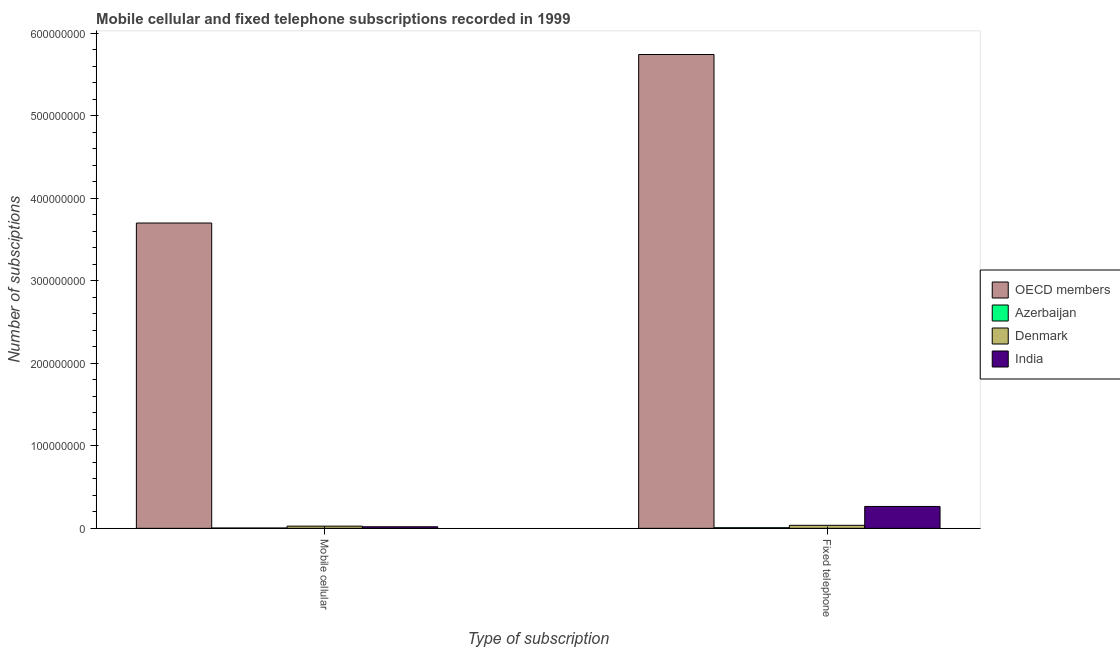How many groups of bars are there?
Your answer should be very brief. 2. What is the label of the 2nd group of bars from the left?
Give a very brief answer. Fixed telephone. What is the number of mobile cellular subscriptions in Denmark?
Keep it short and to the point. 2.63e+06. Across all countries, what is the maximum number of mobile cellular subscriptions?
Provide a short and direct response. 3.70e+08. Across all countries, what is the minimum number of fixed telephone subscriptions?
Keep it short and to the point. 7.30e+05. In which country was the number of mobile cellular subscriptions minimum?
Offer a terse response. Azerbaijan. What is the total number of fixed telephone subscriptions in the graph?
Offer a very short reply. 6.05e+08. What is the difference between the number of fixed telephone subscriptions in Azerbaijan and that in Denmark?
Make the answer very short. -2.91e+06. What is the difference between the number of mobile cellular subscriptions in India and the number of fixed telephone subscriptions in Denmark?
Offer a very short reply. -1.75e+06. What is the average number of fixed telephone subscriptions per country?
Provide a short and direct response. 1.51e+08. What is the difference between the number of mobile cellular subscriptions and number of fixed telephone subscriptions in Azerbaijan?
Make the answer very short. -3.60e+05. What is the ratio of the number of fixed telephone subscriptions in India to that in OECD members?
Your answer should be very brief. 0.05. Is the number of fixed telephone subscriptions in India less than that in Azerbaijan?
Ensure brevity in your answer.  No. In how many countries, is the number of fixed telephone subscriptions greater than the average number of fixed telephone subscriptions taken over all countries?
Offer a terse response. 1. What does the 2nd bar from the left in Fixed telephone represents?
Your response must be concise. Azerbaijan. What does the 4th bar from the right in Mobile cellular represents?
Your answer should be very brief. OECD members. How many countries are there in the graph?
Offer a terse response. 4. Are the values on the major ticks of Y-axis written in scientific E-notation?
Your answer should be very brief. No. Does the graph contain any zero values?
Make the answer very short. No. Does the graph contain grids?
Make the answer very short. No. How many legend labels are there?
Your answer should be compact. 4. What is the title of the graph?
Your answer should be compact. Mobile cellular and fixed telephone subscriptions recorded in 1999. Does "Korea (Democratic)" appear as one of the legend labels in the graph?
Provide a short and direct response. No. What is the label or title of the X-axis?
Provide a short and direct response. Type of subscription. What is the label or title of the Y-axis?
Your answer should be very brief. Number of subsciptions. What is the Number of subsciptions of OECD members in Mobile cellular?
Offer a very short reply. 3.70e+08. What is the Number of subsciptions in Azerbaijan in Mobile cellular?
Your answer should be very brief. 3.70e+05. What is the Number of subsciptions of Denmark in Mobile cellular?
Provide a short and direct response. 2.63e+06. What is the Number of subsciptions of India in Mobile cellular?
Offer a very short reply. 1.88e+06. What is the Number of subsciptions in OECD members in Fixed telephone?
Provide a short and direct response. 5.74e+08. What is the Number of subsciptions of Azerbaijan in Fixed telephone?
Provide a succinct answer. 7.30e+05. What is the Number of subsciptions of Denmark in Fixed telephone?
Provide a short and direct response. 3.64e+06. What is the Number of subsciptions of India in Fixed telephone?
Offer a very short reply. 2.65e+07. Across all Type of subscription, what is the maximum Number of subsciptions in OECD members?
Ensure brevity in your answer.  5.74e+08. Across all Type of subscription, what is the maximum Number of subsciptions of Azerbaijan?
Give a very brief answer. 7.30e+05. Across all Type of subscription, what is the maximum Number of subsciptions in Denmark?
Provide a succinct answer. 3.64e+06. Across all Type of subscription, what is the maximum Number of subsciptions in India?
Offer a very short reply. 2.65e+07. Across all Type of subscription, what is the minimum Number of subsciptions of OECD members?
Make the answer very short. 3.70e+08. Across all Type of subscription, what is the minimum Number of subsciptions in Azerbaijan?
Keep it short and to the point. 3.70e+05. Across all Type of subscription, what is the minimum Number of subsciptions of Denmark?
Offer a terse response. 2.63e+06. Across all Type of subscription, what is the minimum Number of subsciptions in India?
Provide a short and direct response. 1.88e+06. What is the total Number of subsciptions of OECD members in the graph?
Offer a terse response. 9.44e+08. What is the total Number of subsciptions in Azerbaijan in the graph?
Your response must be concise. 1.10e+06. What is the total Number of subsciptions in Denmark in the graph?
Make the answer very short. 6.27e+06. What is the total Number of subsciptions in India in the graph?
Your answer should be compact. 2.84e+07. What is the difference between the Number of subsciptions of OECD members in Mobile cellular and that in Fixed telephone?
Give a very brief answer. -2.04e+08. What is the difference between the Number of subsciptions of Azerbaijan in Mobile cellular and that in Fixed telephone?
Offer a terse response. -3.60e+05. What is the difference between the Number of subsciptions in Denmark in Mobile cellular and that in Fixed telephone?
Ensure brevity in your answer.  -1.01e+06. What is the difference between the Number of subsciptions of India in Mobile cellular and that in Fixed telephone?
Offer a terse response. -2.46e+07. What is the difference between the Number of subsciptions in OECD members in Mobile cellular and the Number of subsciptions in Azerbaijan in Fixed telephone?
Provide a short and direct response. 3.69e+08. What is the difference between the Number of subsciptions in OECD members in Mobile cellular and the Number of subsciptions in Denmark in Fixed telephone?
Provide a succinct answer. 3.66e+08. What is the difference between the Number of subsciptions of OECD members in Mobile cellular and the Number of subsciptions of India in Fixed telephone?
Your answer should be compact. 3.44e+08. What is the difference between the Number of subsciptions of Azerbaijan in Mobile cellular and the Number of subsciptions of Denmark in Fixed telephone?
Keep it short and to the point. -3.27e+06. What is the difference between the Number of subsciptions in Azerbaijan in Mobile cellular and the Number of subsciptions in India in Fixed telephone?
Offer a terse response. -2.61e+07. What is the difference between the Number of subsciptions of Denmark in Mobile cellular and the Number of subsciptions of India in Fixed telephone?
Provide a succinct answer. -2.39e+07. What is the average Number of subsciptions of OECD members per Type of subscription?
Give a very brief answer. 4.72e+08. What is the average Number of subsciptions of Azerbaijan per Type of subscription?
Keep it short and to the point. 5.50e+05. What is the average Number of subsciptions of Denmark per Type of subscription?
Offer a very short reply. 3.13e+06. What is the average Number of subsciptions of India per Type of subscription?
Ensure brevity in your answer.  1.42e+07. What is the difference between the Number of subsciptions of OECD members and Number of subsciptions of Azerbaijan in Mobile cellular?
Keep it short and to the point. 3.70e+08. What is the difference between the Number of subsciptions in OECD members and Number of subsciptions in Denmark in Mobile cellular?
Your answer should be compact. 3.67e+08. What is the difference between the Number of subsciptions of OECD members and Number of subsciptions of India in Mobile cellular?
Offer a very short reply. 3.68e+08. What is the difference between the Number of subsciptions of Azerbaijan and Number of subsciptions of Denmark in Mobile cellular?
Your answer should be very brief. -2.26e+06. What is the difference between the Number of subsciptions of Azerbaijan and Number of subsciptions of India in Mobile cellular?
Offer a very short reply. -1.51e+06. What is the difference between the Number of subsciptions of Denmark and Number of subsciptions of India in Mobile cellular?
Provide a short and direct response. 7.44e+05. What is the difference between the Number of subsciptions in OECD members and Number of subsciptions in Azerbaijan in Fixed telephone?
Keep it short and to the point. 5.74e+08. What is the difference between the Number of subsciptions in OECD members and Number of subsciptions in Denmark in Fixed telephone?
Make the answer very short. 5.71e+08. What is the difference between the Number of subsciptions of OECD members and Number of subsciptions of India in Fixed telephone?
Make the answer very short. 5.48e+08. What is the difference between the Number of subsciptions in Azerbaijan and Number of subsciptions in Denmark in Fixed telephone?
Make the answer very short. -2.91e+06. What is the difference between the Number of subsciptions in Azerbaijan and Number of subsciptions in India in Fixed telephone?
Give a very brief answer. -2.58e+07. What is the difference between the Number of subsciptions in Denmark and Number of subsciptions in India in Fixed telephone?
Ensure brevity in your answer.  -2.29e+07. What is the ratio of the Number of subsciptions of OECD members in Mobile cellular to that in Fixed telephone?
Offer a terse response. 0.64. What is the ratio of the Number of subsciptions in Azerbaijan in Mobile cellular to that in Fixed telephone?
Your response must be concise. 0.51. What is the ratio of the Number of subsciptions of Denmark in Mobile cellular to that in Fixed telephone?
Your answer should be very brief. 0.72. What is the ratio of the Number of subsciptions of India in Mobile cellular to that in Fixed telephone?
Your answer should be very brief. 0.07. What is the difference between the highest and the second highest Number of subsciptions in OECD members?
Keep it short and to the point. 2.04e+08. What is the difference between the highest and the second highest Number of subsciptions of Denmark?
Offer a very short reply. 1.01e+06. What is the difference between the highest and the second highest Number of subsciptions in India?
Your response must be concise. 2.46e+07. What is the difference between the highest and the lowest Number of subsciptions of OECD members?
Your response must be concise. 2.04e+08. What is the difference between the highest and the lowest Number of subsciptions in Denmark?
Make the answer very short. 1.01e+06. What is the difference between the highest and the lowest Number of subsciptions of India?
Offer a terse response. 2.46e+07. 